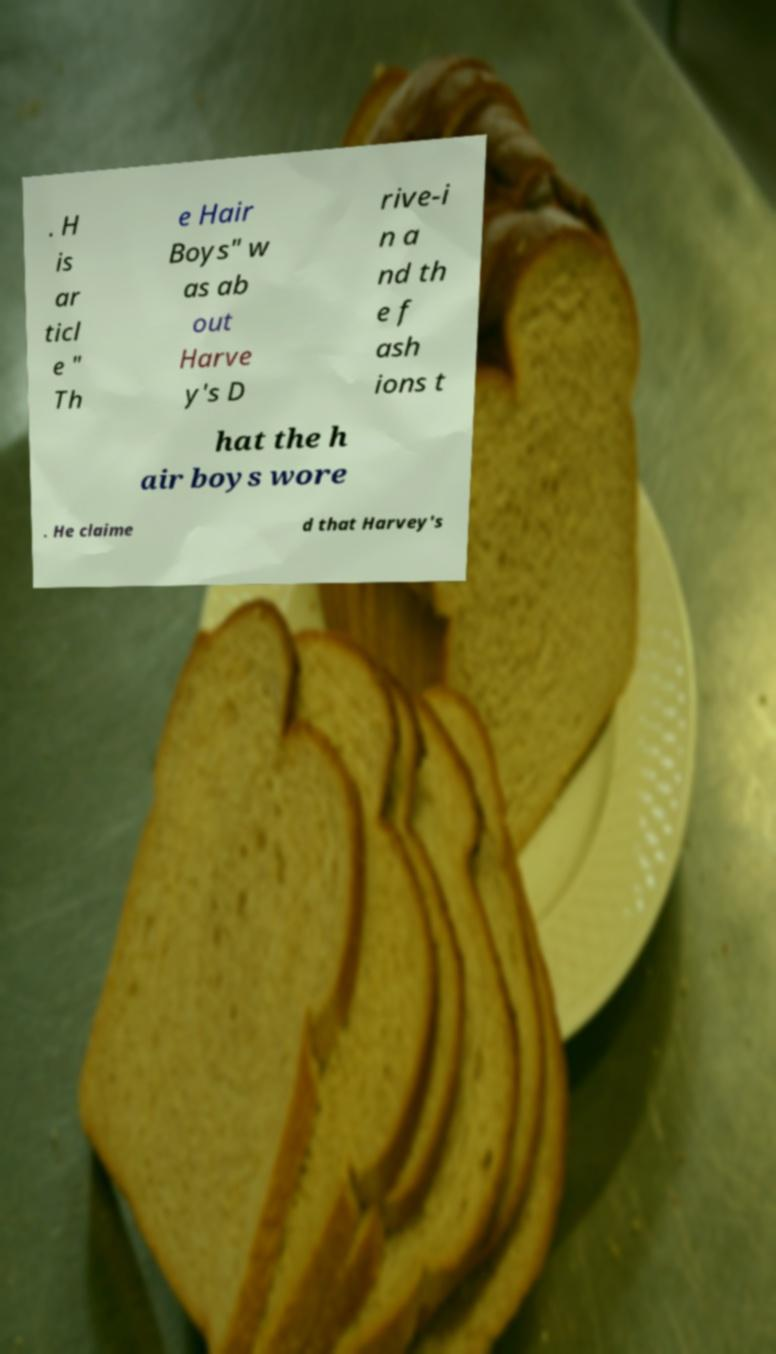Could you extract and type out the text from this image? . H is ar ticl e " Th e Hair Boys" w as ab out Harve y's D rive-i n a nd th e f ash ions t hat the h air boys wore . He claime d that Harvey's 